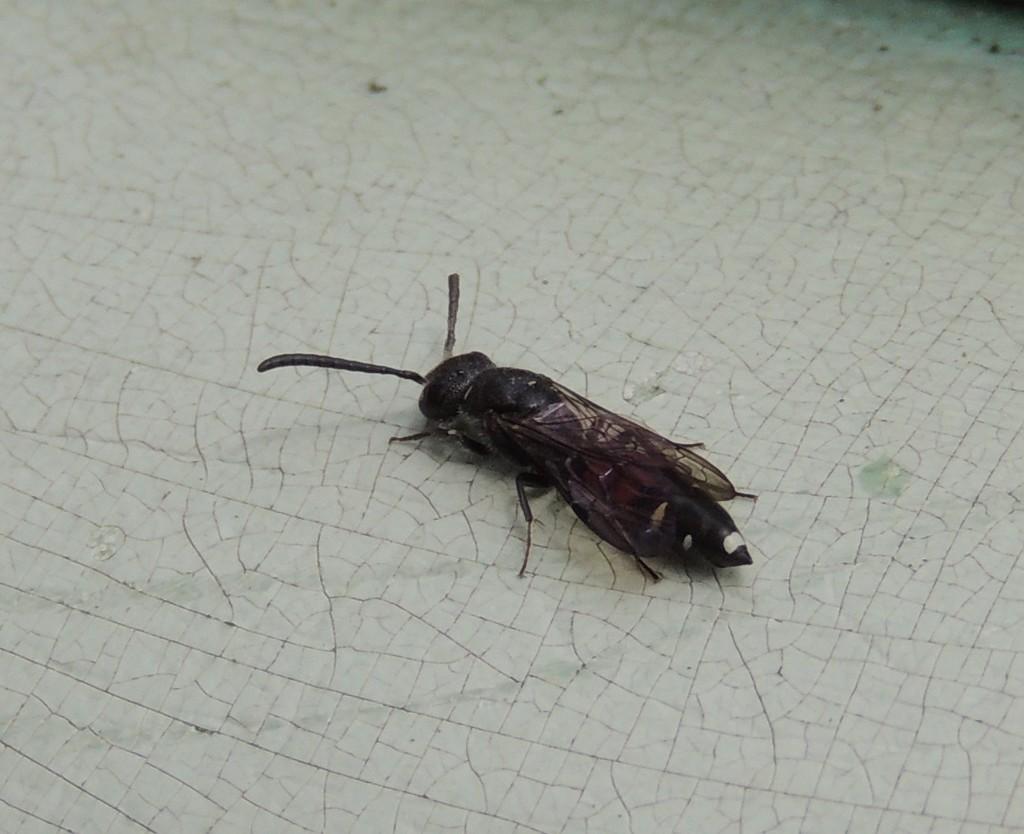Please provide a concise description of this image. In the picture I can see a black color insect on the white color surface. The top of the image is blurred. 